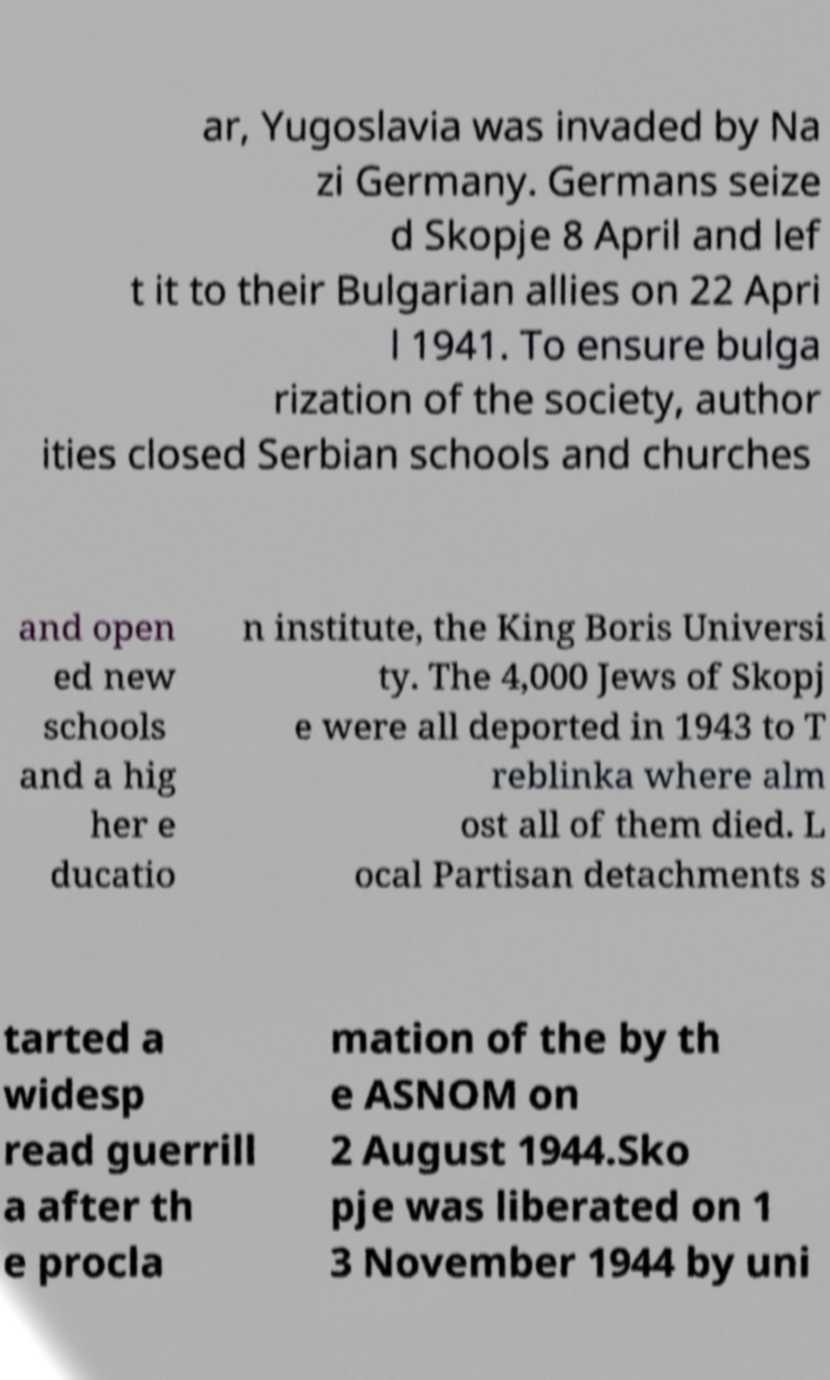Can you read and provide the text displayed in the image?This photo seems to have some interesting text. Can you extract and type it out for me? ar, Yugoslavia was invaded by Na zi Germany. Germans seize d Skopje 8 April and lef t it to their Bulgarian allies on 22 Apri l 1941. To ensure bulga rization of the society, author ities closed Serbian schools and churches and open ed new schools and a hig her e ducatio n institute, the King Boris Universi ty. The 4,000 Jews of Skopj e were all deported in 1943 to T reblinka where alm ost all of them died. L ocal Partisan detachments s tarted a widesp read guerrill a after th e procla mation of the by th e ASNOM on 2 August 1944.Sko pje was liberated on 1 3 November 1944 by uni 